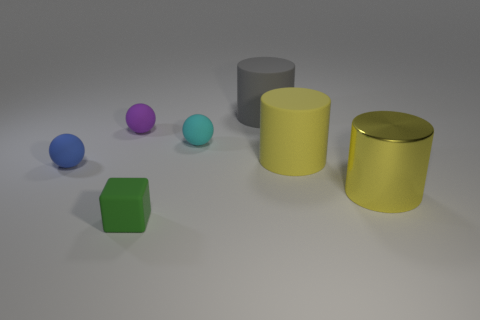Add 1 cyan objects. How many objects exist? 8 Subtract all cylinders. How many objects are left? 4 Subtract all objects. Subtract all large purple shiny things. How many objects are left? 0 Add 4 yellow things. How many yellow things are left? 6 Add 5 tiny cyan matte things. How many tiny cyan matte things exist? 6 Subtract 0 green balls. How many objects are left? 7 